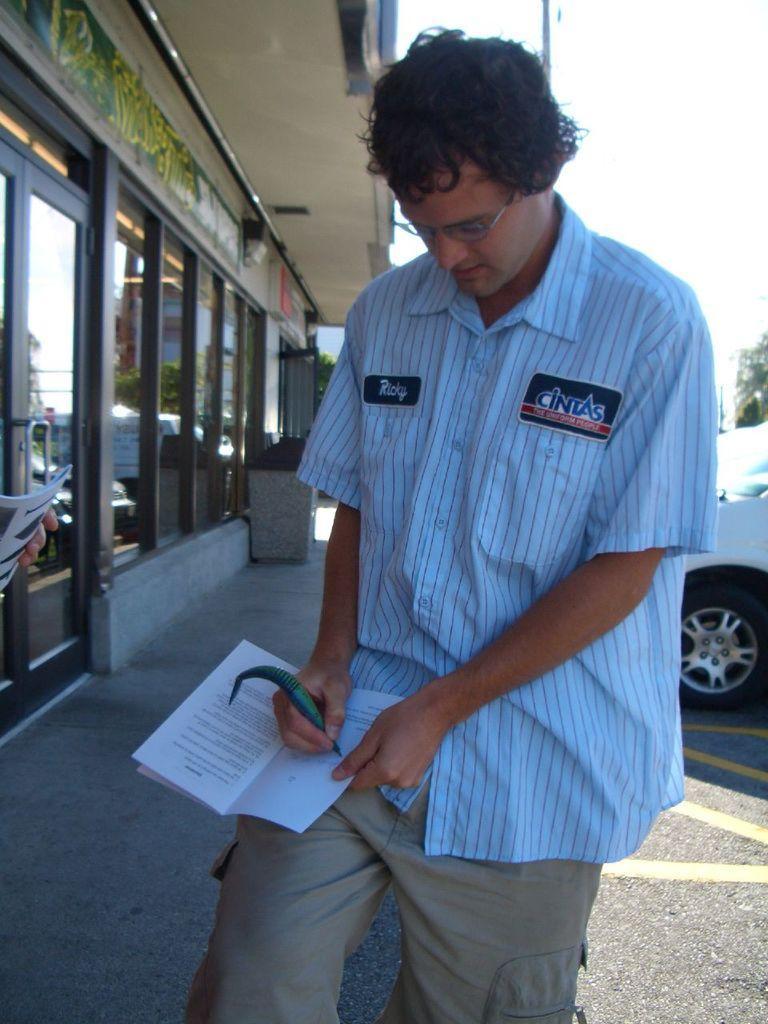Please provide a concise description of this image. In this image in front there is a person holding the book and a pen. Behind him there is a car. On the left side of the image there is a building. At the bottom of the image there is a road. In the background of the image there are trees and sky. 